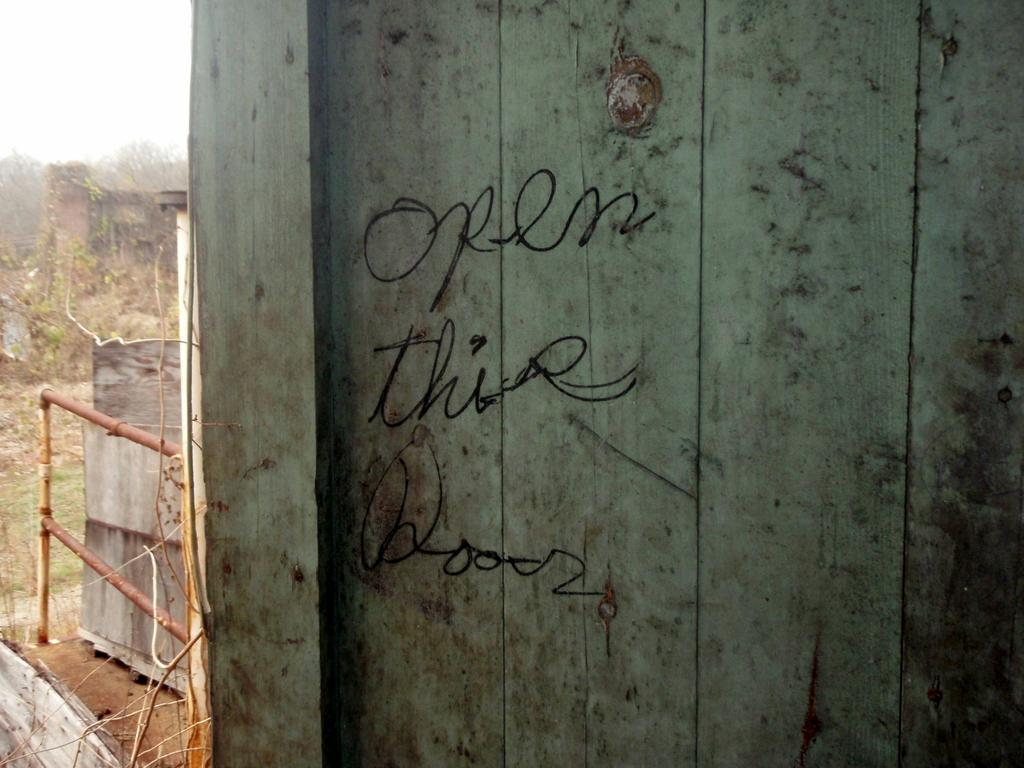What material is the door made of in the image? The door is made of wood. Are there any markings or writing on the door? Yes, there are letters written on the door. What can be seen in the background of the image? There are plants visible in the background. Is there a note attached to the umbrella in the image? There is no umbrella present in the image, so it is not possible to determine if there is a note attached to it. 